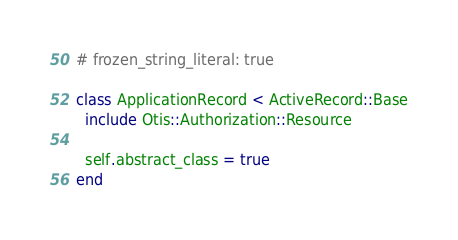Convert code to text. <code><loc_0><loc_0><loc_500><loc_500><_Ruby_># frozen_string_literal: true

class ApplicationRecord < ActiveRecord::Base
  include Otis::Authorization::Resource

  self.abstract_class = true
end
</code> 